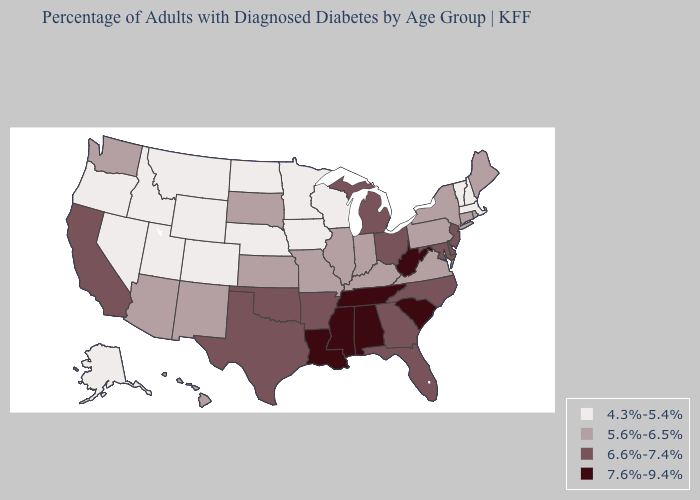Which states have the lowest value in the Northeast?
Answer briefly. Massachusetts, New Hampshire, Vermont. Does Massachusetts have the lowest value in the USA?
Concise answer only. Yes. Which states hav the highest value in the South?
Keep it brief. Alabama, Louisiana, Mississippi, South Carolina, Tennessee, West Virginia. What is the value of Kansas?
Be succinct. 5.6%-6.5%. What is the value of Utah?
Write a very short answer. 4.3%-5.4%. Name the states that have a value in the range 6.6%-7.4%?
Concise answer only. Arkansas, California, Delaware, Florida, Georgia, Maryland, Michigan, New Jersey, North Carolina, Ohio, Oklahoma, Texas. What is the value of Pennsylvania?
Write a very short answer. 5.6%-6.5%. What is the highest value in the South ?
Write a very short answer. 7.6%-9.4%. Name the states that have a value in the range 4.3%-5.4%?
Be succinct. Alaska, Colorado, Idaho, Iowa, Massachusetts, Minnesota, Montana, Nebraska, Nevada, New Hampshire, North Dakota, Oregon, Utah, Vermont, Wisconsin, Wyoming. What is the value of Texas?
Answer briefly. 6.6%-7.4%. What is the lowest value in the South?
Give a very brief answer. 5.6%-6.5%. Does the map have missing data?
Answer briefly. No. What is the highest value in states that border Wyoming?
Short answer required. 5.6%-6.5%. Does Montana have a higher value than Rhode Island?
Keep it brief. No. What is the value of Maryland?
Keep it brief. 6.6%-7.4%. 